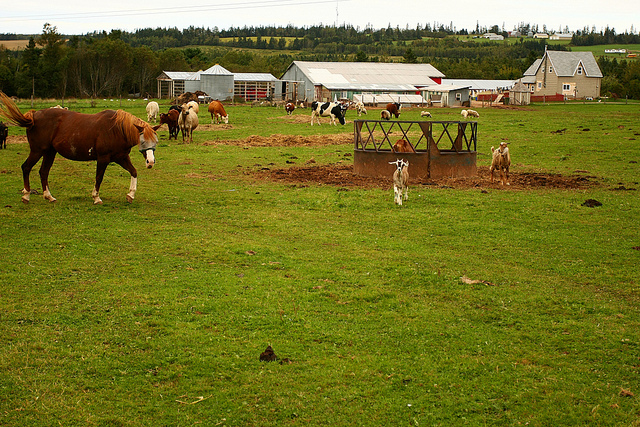<image>What is the copyright date on the image? It is unknown what the copyright date on the image is. It can be '2016', '2002', '2013', or '10 10 2001'. What is the copyright date on the image? It is unknown what is the copyright date on the image. There is no information provided. 